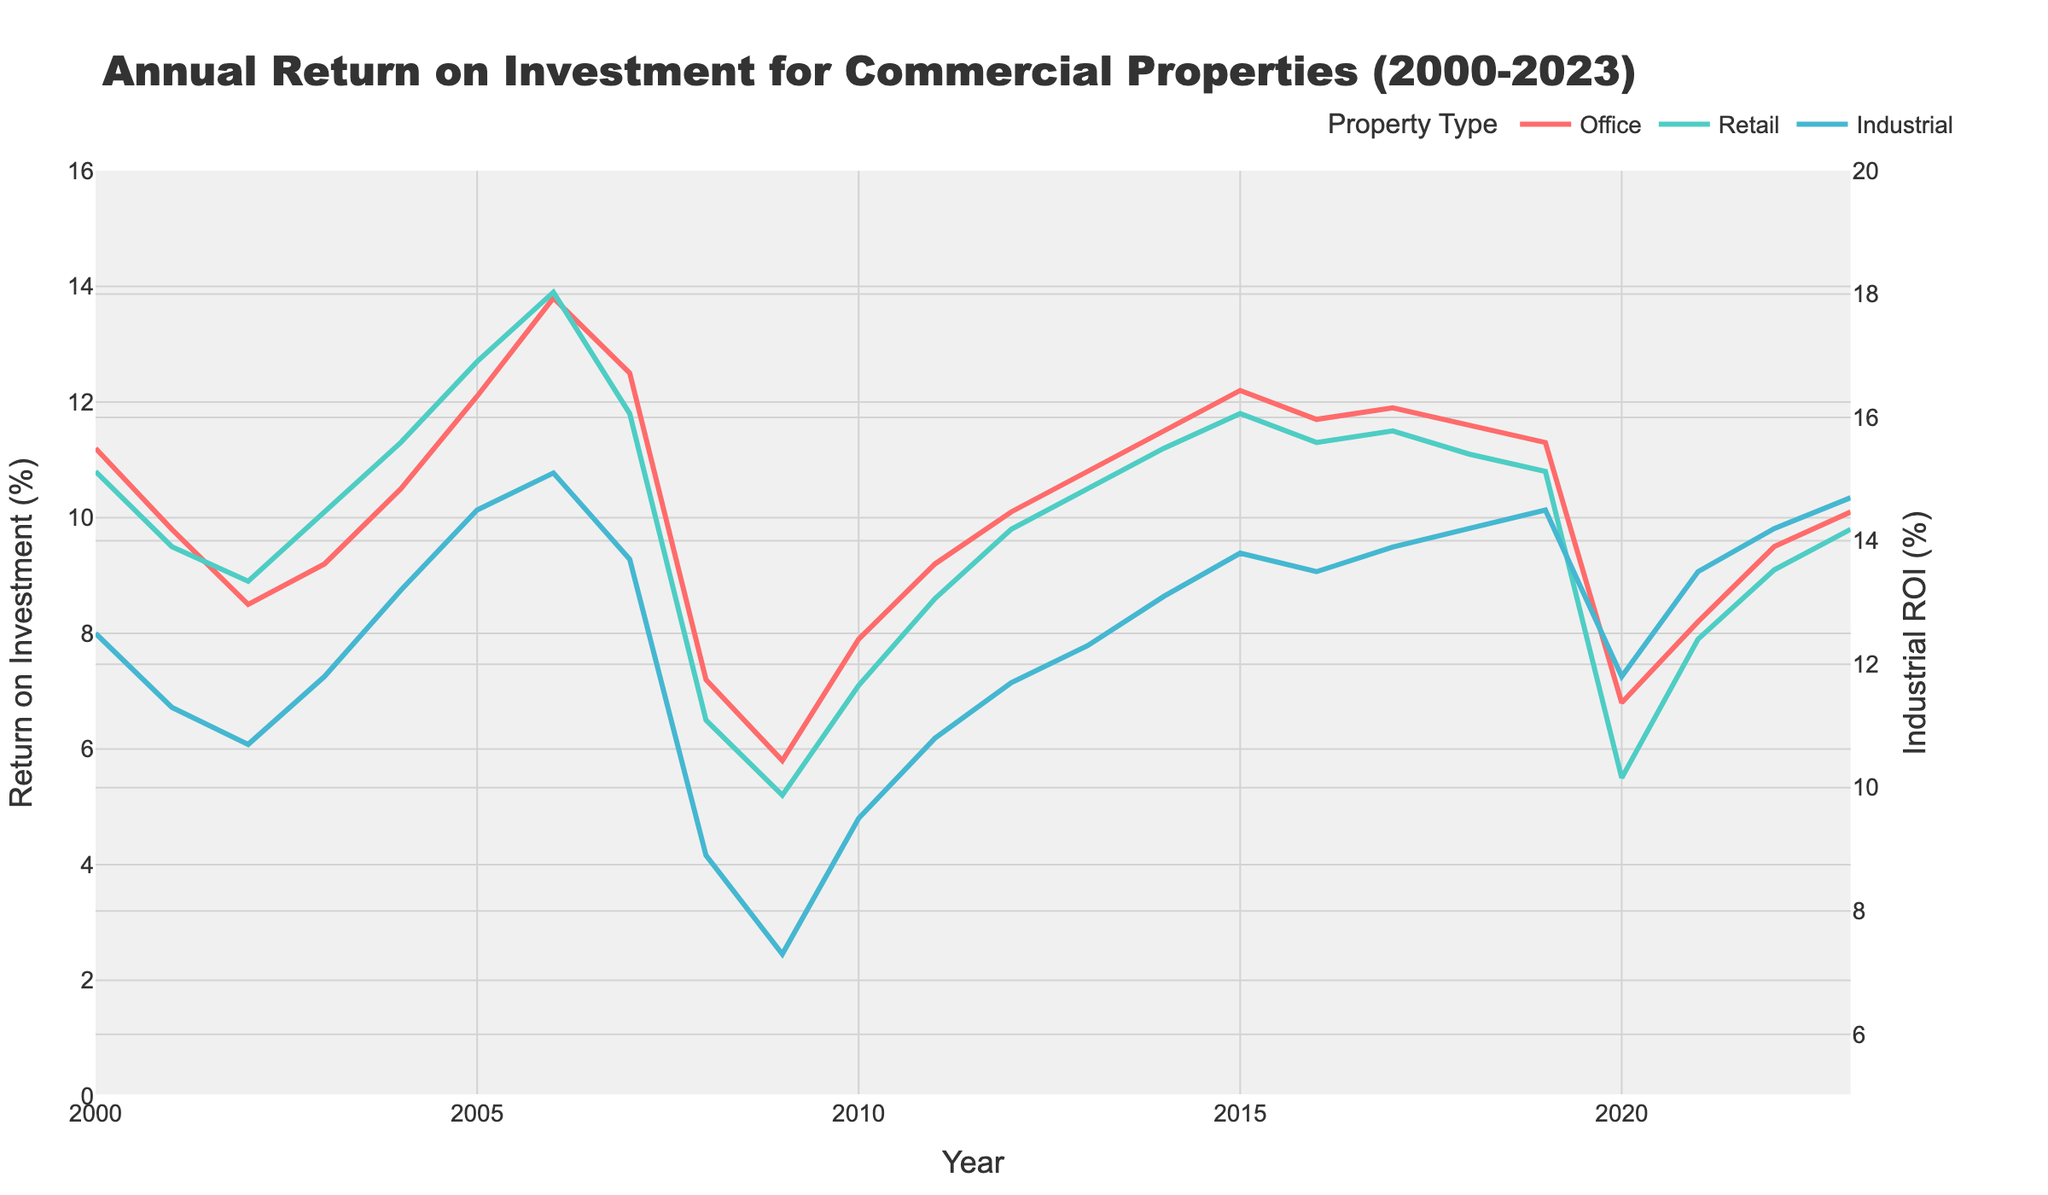Which property type had the highest return on investment in 2023? Look at the end of the lines on the right side of the chart and identify which line is the highest in 2023. The Industrial property type had the highest point at 14.7% in 2023.
Answer: Industrial Which year saw the lowest return on investment for Retail properties? Find the lowest point on the green line that represents Retail properties. The lowest point is in 2009 where the return was 5.2%.
Answer: 2009 Compare the return on investment for Office properties in 2008 and 2020. Which year had a higher return? Find the points corresponding to Office properties for the years 2008 and 2020. In 2008, the return was 7.2%, whereas in 2020 it was 6.8%. Therefore, 2008 had a higher return.
Answer: 2008 What was the overall trend for Industrial properties between 2000 and 2023? Observe the overall direction of the blue line from the start to the end of the plot. The trend shows a general increase, as the line goes from 12.5% in 2000 to 14.7% in 2023 with some fluctuations.
Answer: Increasing Which property type bounced back the most after the 2009 dip? Compare the initial dip levels and the subsequent recovery for all three property types from 2009 to the following years. Industrial properties increased from 7.3% in 2009 to 9.5% in 2010, Retail properties increased from 5.2% to 7.1%, and Office properties increased from 5.8% to 7.9%. Thus, Office properties had the largest bounce back.
Answer: Office In how many years did Retail properties have a higher return on investment than Office properties between 2000 and 2023? Compare the green and red lines year by year and count the number of crossings where the green line (Retail) is above the red line (Office). Retail properties had a higher return in 2002, 2003, 2007, 2008, 2009, 2010, 2011, 2016, and 2020, totaling 9 years.
Answer: 9 What is the average return on investment for Office properties from 2000 to 2023? Sum up all the data points for Office properties and divide by the number of years (24). The calculation is (11.2+9.8+8.5+9.2+10.5+12.1+13.8+12.5+7.2+5.8+7.9+9.2+10.1+10.8+11.5+12.2+11.7+11.9+11.6+11.3+6.8+8.2+9.5+10.1) / 24 = 10.165% (approx).
Answer: 10.2% 